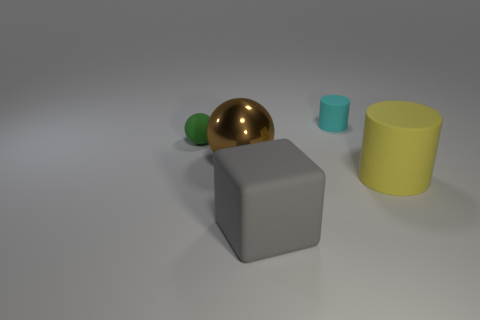Add 1 large brown spheres. How many objects exist? 6 Subtract all cylinders. How many objects are left? 3 Subtract all big rubber cubes. Subtract all small purple rubber blocks. How many objects are left? 4 Add 1 big brown metal things. How many big brown metal things are left? 2 Add 1 big purple metallic cubes. How many big purple metallic cubes exist? 1 Subtract 0 brown blocks. How many objects are left? 5 